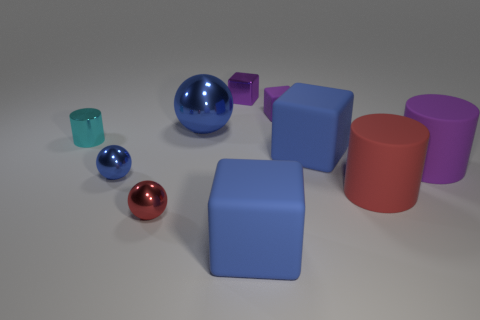Subtract all cubes. How many objects are left? 6 Add 6 blue metal things. How many blue metal things exist? 8 Subtract 1 red cylinders. How many objects are left? 9 Subtract all small purple objects. Subtract all red matte things. How many objects are left? 7 Add 1 tiny metal spheres. How many tiny metal spheres are left? 3 